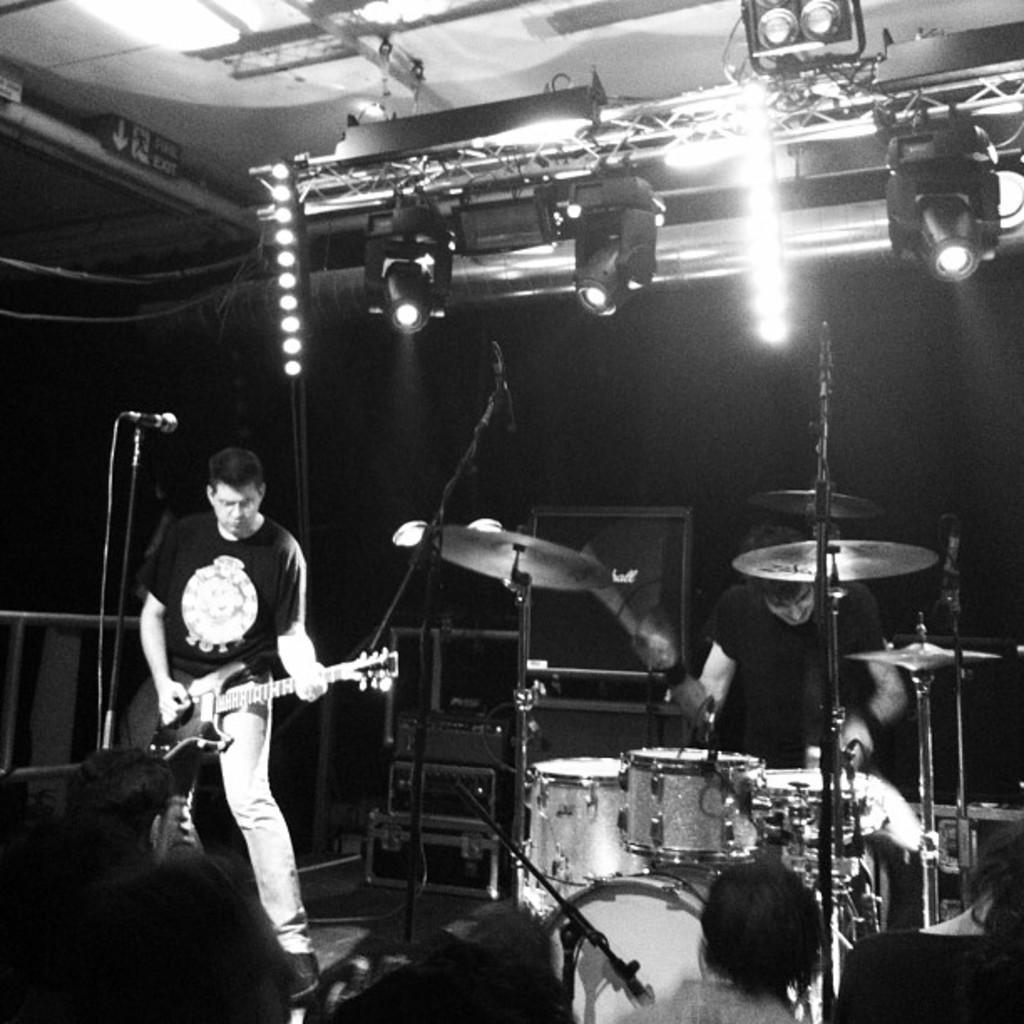Describe this image in one or two sentences. In this picture there are two people holding some musical instruments and playing it and behind them there are some speakers and to the roof there are some lights. 